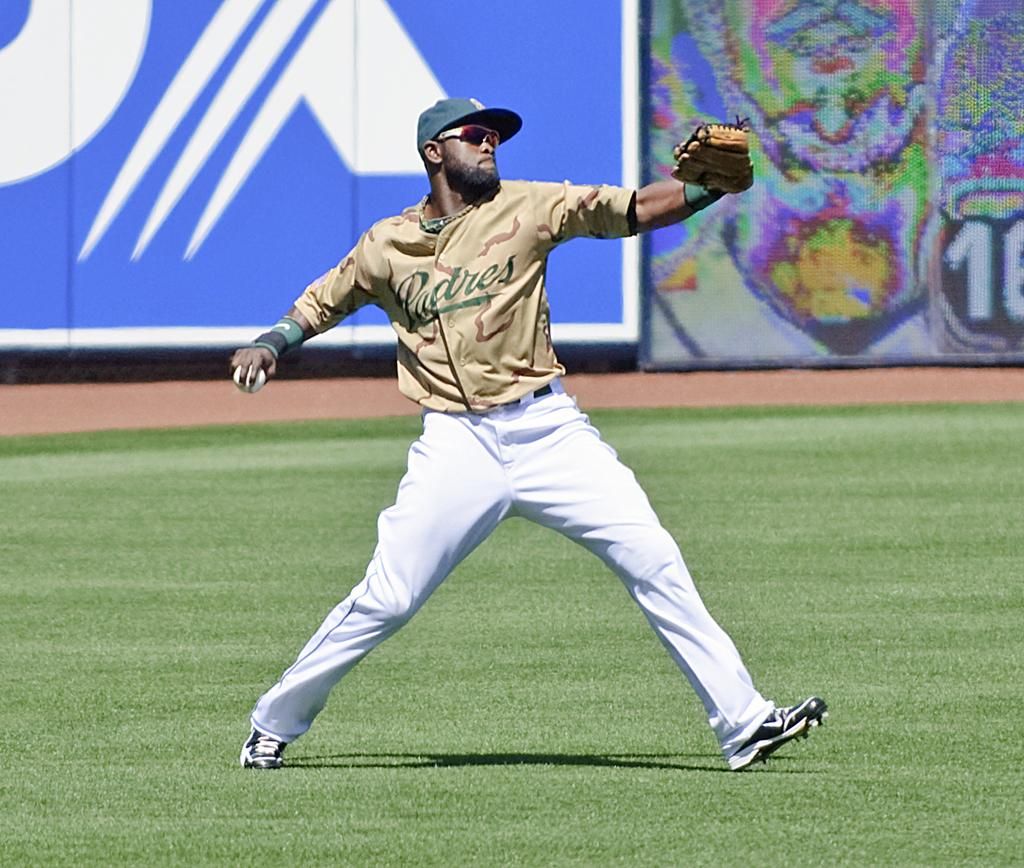<image>
Give a short and clear explanation of the subsequent image. A baseball player from the Padres is throwing a ball. 